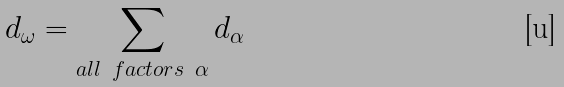<formula> <loc_0><loc_0><loc_500><loc_500>d _ { \omega } = \sum _ { a l l \ f a c t o r s \ \alpha } d _ { \alpha }</formula> 